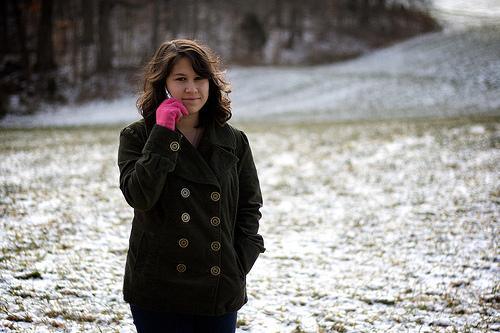Narrate the action being performed by the person in the photograph. The woman in the picture seems to be engaged in a conversation using her cell phone, with her right hand in a pink glove holding the device close to her ear. Describe a close-up view of the woman's face and hair. The young woman displays a focused expression with her eyes directed at her cell phone, while her brown curls cascade around her face, reaching down to her shoulders. List three distinct features of the woman's attire. The woman is dressed in a dark green peacoat with wide lapels, bright pink gloves covering her hands, and blue jeans visible below her coat. Mention the most important object in the image and its main features. The key object is a young woman in a green coat with wide lapels and brassy buttons, holding a cell phone while sporting bright pink gloves on her hands. Write about the color palette of the items featured in the photograph. The image mainly consists of shades of green from the woman's coat, with contrasting elements in pink for her gloves and varying shades of white and blue for the snow-covered landscape. Explain the condition of the landscape in the photograph. The scene captures a cold winter day with fresh snow covering hilly ground, grass peeking through in some spots, and a dense grouping of leafless trees in the background. Identify the activity taking place in the image and its setting. A young woman is talking on the phone, standing outside in a snow-covered field with rolling hills and a backdrop of bare trees. Provide a brief overview of the scene in the image. A young woman with wavy brown hair, wearing a dark green peacoat and pink gloves, is talking on her cell phone outside in a snow-covered field with bare trees and rolling hills. Describe the natural environment shown in the image. The image depicts a snowy landscape with a thin layer of snow covering the grassy ground, bare trees behind a rolling hill, and hills in the distance. What distinctive clothing item is the woman wearing? The woman is wearing a pair of bright pink gloves, adding a splash of color to her otherwise dark and wintery outfit. 